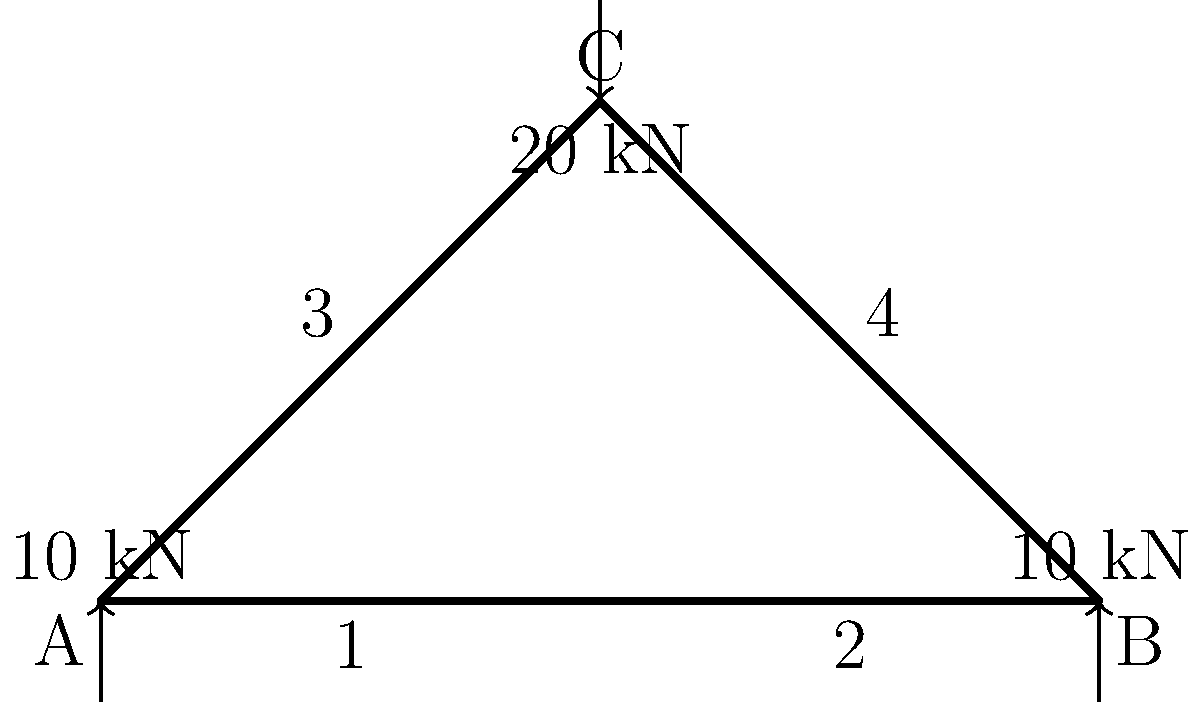In the truss bridge structure shown above, determine the axial force in member 3. Assume all joints are pin connections and the structure is in equilibrium. Is the member in tension or compression? To solve this problem, we'll use the method of joints, focusing on joint C. Here's a step-by-step approach:

1) First, we need to establish the sign convention: tension forces are positive, compression forces are negative.

2) At joint C, we have three unknown forces: the forces in members 3, 4, and the 20 kN external load.

3) We can set up two equations of equilibrium for joint C:

   Vertical forces: $\sum F_y = 0$
   Horizontal forces: $\sum F_x = 0$

4) From the geometry, we can see that members 3 and 4 are symmetrical and form a 45-degree angle with the horizontal.

5) Let's denote the force in member 3 as $F_3$ and in member 4 as $F_4$. Due to symmetry, $F_3 = F_4$.

6) Resolving forces vertically:
   $F_3 \cdot \sin(45°) + F_4 \cdot \sin(45°) - 20 = 0$
   $F_3 \cdot \frac{\sqrt{2}}{2} + F_3 \cdot \frac{\sqrt{2}}{2} - 20 = 0$
   $F_3 \cdot \sqrt{2} - 20 = 0$

7) Solving for $F_3$:
   $F_3 = \frac{20}{\sqrt{2}} = 20 \cdot \frac{\sqrt{2}}{2} \approx 14.14$ kN

8) The positive value indicates that member 3 is in tension.
Answer: 14.14 kN (tension) 